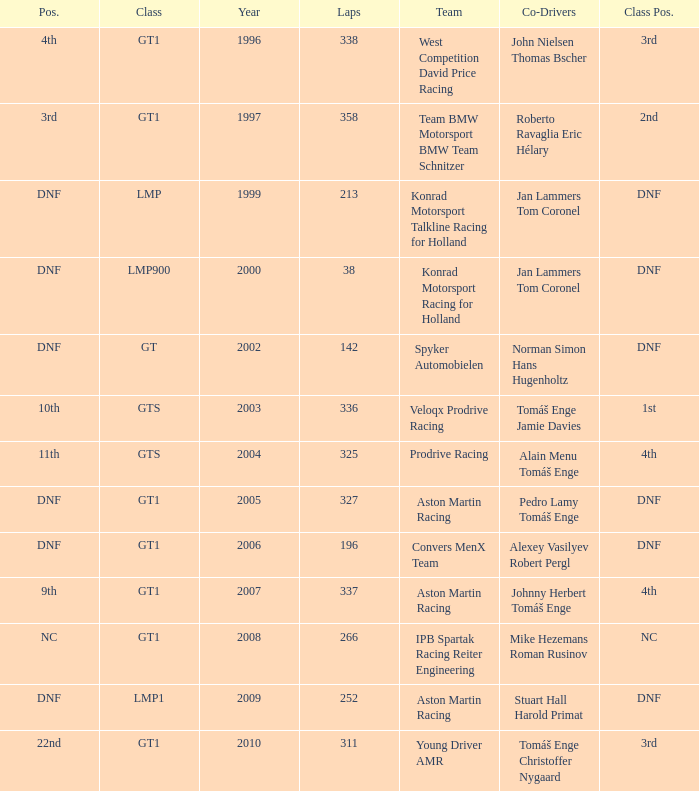In which class had 252 laps and a position of dnf? LMP1. 